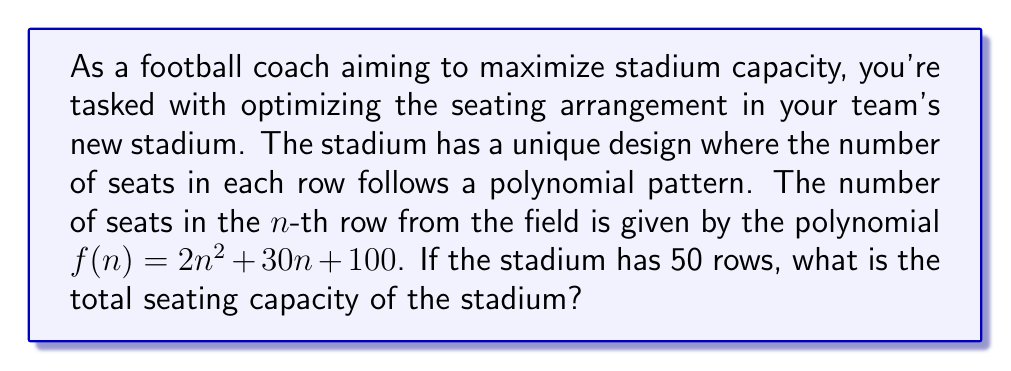Solve this math problem. To solve this problem, we need to sum up the number of seats in each row from 1 to 50. This is equivalent to finding the sum of the polynomial $f(n) = 2n^2 + 30n + 100$ for $n$ from 1 to 50.

Let's break this down step-by-step:

1) We need to calculate $\sum_{n=1}^{50} (2n^2 + 30n + 100)$

2) This sum can be split into three parts:
   $2\sum_{n=1}^{50} n^2 + 30\sum_{n=1}^{50} n + 100\sum_{n=1}^{50} 1$

3) We can use the following formulas:
   $\sum_{n=1}^{k} n^2 = \frac{k(k+1)(2k+1)}{6}$
   $\sum_{n=1}^{k} n = \frac{k(k+1)}{2}$
   $\sum_{n=1}^{k} 1 = k$

4) Substituting $k = 50$:
   $2 \cdot \frac{50(51)(101)}{6} + 30 \cdot \frac{50(51)}{2} + 100 \cdot 50$

5) Simplifying:
   $2 \cdot 42925 + 30 \cdot 1275 + 5000$
   $= 85850 + 38250 + 5000$
   $= 129100$

Therefore, the total seating capacity of the stadium is 129,100 seats.
Answer: 129,100 seats 